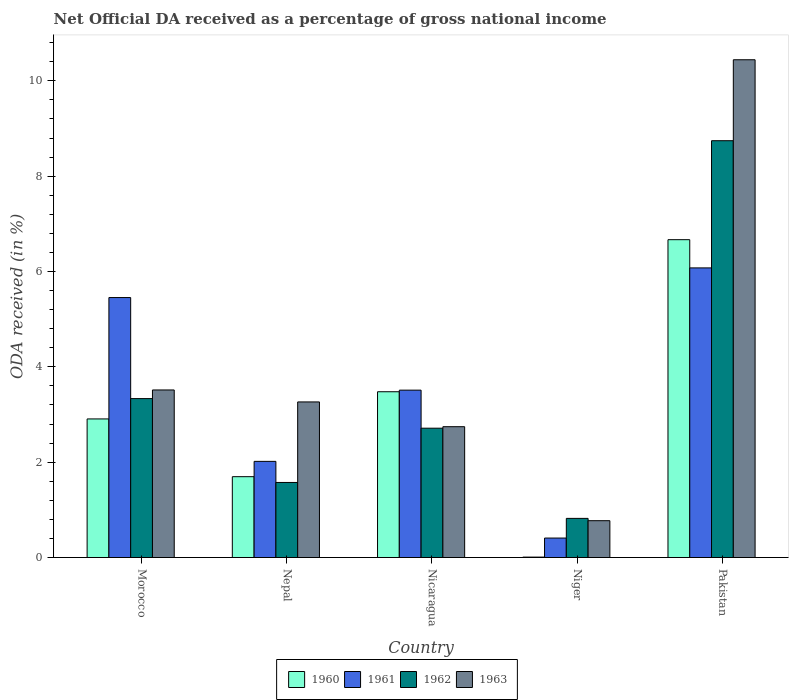How many groups of bars are there?
Offer a very short reply. 5. Are the number of bars per tick equal to the number of legend labels?
Your answer should be compact. Yes. How many bars are there on the 1st tick from the left?
Your response must be concise. 4. How many bars are there on the 3rd tick from the right?
Provide a succinct answer. 4. What is the label of the 4th group of bars from the left?
Make the answer very short. Niger. What is the net official DA received in 1963 in Nepal?
Your answer should be very brief. 3.26. Across all countries, what is the maximum net official DA received in 1963?
Provide a succinct answer. 10.44. Across all countries, what is the minimum net official DA received in 1962?
Make the answer very short. 0.82. In which country was the net official DA received in 1962 maximum?
Offer a terse response. Pakistan. In which country was the net official DA received in 1963 minimum?
Your response must be concise. Niger. What is the total net official DA received in 1962 in the graph?
Your answer should be compact. 17.19. What is the difference between the net official DA received in 1963 in Nicaragua and that in Niger?
Keep it short and to the point. 1.97. What is the difference between the net official DA received in 1963 in Pakistan and the net official DA received in 1962 in Morocco?
Your answer should be compact. 7.11. What is the average net official DA received in 1960 per country?
Provide a succinct answer. 2.95. What is the difference between the net official DA received of/in 1962 and net official DA received of/in 1960 in Nepal?
Give a very brief answer. -0.12. What is the ratio of the net official DA received in 1961 in Nepal to that in Nicaragua?
Ensure brevity in your answer.  0.57. Is the net official DA received in 1961 in Morocco less than that in Nicaragua?
Your answer should be compact. No. What is the difference between the highest and the second highest net official DA received in 1961?
Make the answer very short. -1.94. What is the difference between the highest and the lowest net official DA received in 1960?
Your answer should be compact. 6.66. In how many countries, is the net official DA received in 1962 greater than the average net official DA received in 1962 taken over all countries?
Your answer should be compact. 1. Is it the case that in every country, the sum of the net official DA received in 1963 and net official DA received in 1961 is greater than the net official DA received in 1962?
Your answer should be very brief. Yes. How many bars are there?
Ensure brevity in your answer.  20. Are all the bars in the graph horizontal?
Ensure brevity in your answer.  No. Are the values on the major ticks of Y-axis written in scientific E-notation?
Keep it short and to the point. No. Does the graph contain grids?
Offer a terse response. No. What is the title of the graph?
Provide a short and direct response. Net Official DA received as a percentage of gross national income. Does "1988" appear as one of the legend labels in the graph?
Keep it short and to the point. No. What is the label or title of the Y-axis?
Your answer should be compact. ODA received (in %). What is the ODA received (in %) of 1960 in Morocco?
Give a very brief answer. 2.91. What is the ODA received (in %) in 1961 in Morocco?
Offer a very short reply. 5.45. What is the ODA received (in %) of 1962 in Morocco?
Keep it short and to the point. 3.33. What is the ODA received (in %) of 1963 in Morocco?
Make the answer very short. 3.51. What is the ODA received (in %) in 1960 in Nepal?
Make the answer very short. 1.7. What is the ODA received (in %) of 1961 in Nepal?
Give a very brief answer. 2.02. What is the ODA received (in %) in 1962 in Nepal?
Your answer should be very brief. 1.57. What is the ODA received (in %) of 1963 in Nepal?
Your answer should be very brief. 3.26. What is the ODA received (in %) in 1960 in Nicaragua?
Your answer should be very brief. 3.48. What is the ODA received (in %) in 1961 in Nicaragua?
Offer a terse response. 3.51. What is the ODA received (in %) of 1962 in Nicaragua?
Provide a short and direct response. 2.71. What is the ODA received (in %) in 1963 in Nicaragua?
Your response must be concise. 2.74. What is the ODA received (in %) of 1960 in Niger?
Keep it short and to the point. 0.01. What is the ODA received (in %) in 1961 in Niger?
Your answer should be compact. 0.41. What is the ODA received (in %) of 1962 in Niger?
Provide a short and direct response. 0.82. What is the ODA received (in %) of 1963 in Niger?
Your answer should be compact. 0.77. What is the ODA received (in %) in 1960 in Pakistan?
Your response must be concise. 6.67. What is the ODA received (in %) of 1961 in Pakistan?
Your answer should be compact. 6.08. What is the ODA received (in %) in 1962 in Pakistan?
Keep it short and to the point. 8.74. What is the ODA received (in %) of 1963 in Pakistan?
Ensure brevity in your answer.  10.44. Across all countries, what is the maximum ODA received (in %) in 1960?
Your answer should be very brief. 6.67. Across all countries, what is the maximum ODA received (in %) in 1961?
Make the answer very short. 6.08. Across all countries, what is the maximum ODA received (in %) of 1962?
Your answer should be compact. 8.74. Across all countries, what is the maximum ODA received (in %) of 1963?
Your answer should be very brief. 10.44. Across all countries, what is the minimum ODA received (in %) of 1960?
Ensure brevity in your answer.  0.01. Across all countries, what is the minimum ODA received (in %) of 1961?
Make the answer very short. 0.41. Across all countries, what is the minimum ODA received (in %) in 1962?
Make the answer very short. 0.82. Across all countries, what is the minimum ODA received (in %) of 1963?
Give a very brief answer. 0.77. What is the total ODA received (in %) of 1960 in the graph?
Provide a short and direct response. 14.76. What is the total ODA received (in %) in 1961 in the graph?
Keep it short and to the point. 17.46. What is the total ODA received (in %) in 1962 in the graph?
Ensure brevity in your answer.  17.19. What is the total ODA received (in %) in 1963 in the graph?
Ensure brevity in your answer.  20.74. What is the difference between the ODA received (in %) in 1960 in Morocco and that in Nepal?
Provide a succinct answer. 1.21. What is the difference between the ODA received (in %) in 1961 in Morocco and that in Nepal?
Offer a terse response. 3.44. What is the difference between the ODA received (in %) of 1962 in Morocco and that in Nepal?
Your answer should be compact. 1.76. What is the difference between the ODA received (in %) in 1963 in Morocco and that in Nepal?
Your answer should be very brief. 0.25. What is the difference between the ODA received (in %) of 1960 in Morocco and that in Nicaragua?
Your answer should be very brief. -0.57. What is the difference between the ODA received (in %) of 1961 in Morocco and that in Nicaragua?
Offer a terse response. 1.94. What is the difference between the ODA received (in %) in 1962 in Morocco and that in Nicaragua?
Provide a succinct answer. 0.62. What is the difference between the ODA received (in %) of 1963 in Morocco and that in Nicaragua?
Your answer should be compact. 0.77. What is the difference between the ODA received (in %) in 1960 in Morocco and that in Niger?
Offer a terse response. 2.9. What is the difference between the ODA received (in %) of 1961 in Morocco and that in Niger?
Your answer should be very brief. 5.05. What is the difference between the ODA received (in %) in 1962 in Morocco and that in Niger?
Provide a succinct answer. 2.51. What is the difference between the ODA received (in %) in 1963 in Morocco and that in Niger?
Provide a succinct answer. 2.74. What is the difference between the ODA received (in %) of 1960 in Morocco and that in Pakistan?
Make the answer very short. -3.76. What is the difference between the ODA received (in %) in 1961 in Morocco and that in Pakistan?
Provide a succinct answer. -0.62. What is the difference between the ODA received (in %) of 1962 in Morocco and that in Pakistan?
Give a very brief answer. -5.41. What is the difference between the ODA received (in %) of 1963 in Morocco and that in Pakistan?
Your response must be concise. -6.93. What is the difference between the ODA received (in %) in 1960 in Nepal and that in Nicaragua?
Give a very brief answer. -1.78. What is the difference between the ODA received (in %) of 1961 in Nepal and that in Nicaragua?
Offer a very short reply. -1.49. What is the difference between the ODA received (in %) in 1962 in Nepal and that in Nicaragua?
Provide a short and direct response. -1.14. What is the difference between the ODA received (in %) of 1963 in Nepal and that in Nicaragua?
Your answer should be compact. 0.52. What is the difference between the ODA received (in %) in 1960 in Nepal and that in Niger?
Keep it short and to the point. 1.69. What is the difference between the ODA received (in %) of 1961 in Nepal and that in Niger?
Provide a short and direct response. 1.61. What is the difference between the ODA received (in %) in 1962 in Nepal and that in Niger?
Your answer should be compact. 0.75. What is the difference between the ODA received (in %) of 1963 in Nepal and that in Niger?
Your answer should be very brief. 2.49. What is the difference between the ODA received (in %) of 1960 in Nepal and that in Pakistan?
Provide a short and direct response. -4.97. What is the difference between the ODA received (in %) of 1961 in Nepal and that in Pakistan?
Provide a short and direct response. -4.06. What is the difference between the ODA received (in %) of 1962 in Nepal and that in Pakistan?
Your response must be concise. -7.17. What is the difference between the ODA received (in %) of 1963 in Nepal and that in Pakistan?
Keep it short and to the point. -7.18. What is the difference between the ODA received (in %) in 1960 in Nicaragua and that in Niger?
Offer a terse response. 3.47. What is the difference between the ODA received (in %) of 1961 in Nicaragua and that in Niger?
Keep it short and to the point. 3.1. What is the difference between the ODA received (in %) of 1962 in Nicaragua and that in Niger?
Give a very brief answer. 1.89. What is the difference between the ODA received (in %) of 1963 in Nicaragua and that in Niger?
Your response must be concise. 1.97. What is the difference between the ODA received (in %) in 1960 in Nicaragua and that in Pakistan?
Offer a very short reply. -3.19. What is the difference between the ODA received (in %) of 1961 in Nicaragua and that in Pakistan?
Provide a short and direct response. -2.56. What is the difference between the ODA received (in %) in 1962 in Nicaragua and that in Pakistan?
Give a very brief answer. -6.03. What is the difference between the ODA received (in %) of 1963 in Nicaragua and that in Pakistan?
Your answer should be very brief. -7.7. What is the difference between the ODA received (in %) of 1960 in Niger and that in Pakistan?
Ensure brevity in your answer.  -6.66. What is the difference between the ODA received (in %) in 1961 in Niger and that in Pakistan?
Your response must be concise. -5.67. What is the difference between the ODA received (in %) of 1962 in Niger and that in Pakistan?
Your response must be concise. -7.92. What is the difference between the ODA received (in %) of 1963 in Niger and that in Pakistan?
Your response must be concise. -9.67. What is the difference between the ODA received (in %) of 1960 in Morocco and the ODA received (in %) of 1961 in Nepal?
Offer a terse response. 0.89. What is the difference between the ODA received (in %) of 1960 in Morocco and the ODA received (in %) of 1962 in Nepal?
Make the answer very short. 1.33. What is the difference between the ODA received (in %) of 1960 in Morocco and the ODA received (in %) of 1963 in Nepal?
Ensure brevity in your answer.  -0.36. What is the difference between the ODA received (in %) in 1961 in Morocco and the ODA received (in %) in 1962 in Nepal?
Offer a terse response. 3.88. What is the difference between the ODA received (in %) in 1961 in Morocco and the ODA received (in %) in 1963 in Nepal?
Keep it short and to the point. 2.19. What is the difference between the ODA received (in %) in 1962 in Morocco and the ODA received (in %) in 1963 in Nepal?
Give a very brief answer. 0.07. What is the difference between the ODA received (in %) in 1960 in Morocco and the ODA received (in %) in 1961 in Nicaragua?
Your answer should be very brief. -0.6. What is the difference between the ODA received (in %) in 1960 in Morocco and the ODA received (in %) in 1962 in Nicaragua?
Keep it short and to the point. 0.19. What is the difference between the ODA received (in %) in 1960 in Morocco and the ODA received (in %) in 1963 in Nicaragua?
Ensure brevity in your answer.  0.16. What is the difference between the ODA received (in %) in 1961 in Morocco and the ODA received (in %) in 1962 in Nicaragua?
Offer a very short reply. 2.74. What is the difference between the ODA received (in %) of 1961 in Morocco and the ODA received (in %) of 1963 in Nicaragua?
Your answer should be very brief. 2.71. What is the difference between the ODA received (in %) in 1962 in Morocco and the ODA received (in %) in 1963 in Nicaragua?
Offer a very short reply. 0.59. What is the difference between the ODA received (in %) in 1960 in Morocco and the ODA received (in %) in 1961 in Niger?
Your response must be concise. 2.5. What is the difference between the ODA received (in %) of 1960 in Morocco and the ODA received (in %) of 1962 in Niger?
Provide a short and direct response. 2.09. What is the difference between the ODA received (in %) of 1960 in Morocco and the ODA received (in %) of 1963 in Niger?
Offer a very short reply. 2.13. What is the difference between the ODA received (in %) in 1961 in Morocco and the ODA received (in %) in 1962 in Niger?
Offer a terse response. 4.63. What is the difference between the ODA received (in %) of 1961 in Morocco and the ODA received (in %) of 1963 in Niger?
Offer a very short reply. 4.68. What is the difference between the ODA received (in %) of 1962 in Morocco and the ODA received (in %) of 1963 in Niger?
Provide a succinct answer. 2.56. What is the difference between the ODA received (in %) of 1960 in Morocco and the ODA received (in %) of 1961 in Pakistan?
Offer a terse response. -3.17. What is the difference between the ODA received (in %) of 1960 in Morocco and the ODA received (in %) of 1962 in Pakistan?
Your response must be concise. -5.84. What is the difference between the ODA received (in %) of 1960 in Morocco and the ODA received (in %) of 1963 in Pakistan?
Offer a terse response. -7.53. What is the difference between the ODA received (in %) of 1961 in Morocco and the ODA received (in %) of 1962 in Pakistan?
Make the answer very short. -3.29. What is the difference between the ODA received (in %) in 1961 in Morocco and the ODA received (in %) in 1963 in Pakistan?
Your response must be concise. -4.99. What is the difference between the ODA received (in %) of 1962 in Morocco and the ODA received (in %) of 1963 in Pakistan?
Offer a terse response. -7.11. What is the difference between the ODA received (in %) of 1960 in Nepal and the ODA received (in %) of 1961 in Nicaragua?
Your response must be concise. -1.82. What is the difference between the ODA received (in %) of 1960 in Nepal and the ODA received (in %) of 1962 in Nicaragua?
Ensure brevity in your answer.  -1.02. What is the difference between the ODA received (in %) in 1960 in Nepal and the ODA received (in %) in 1963 in Nicaragua?
Your answer should be very brief. -1.05. What is the difference between the ODA received (in %) of 1961 in Nepal and the ODA received (in %) of 1962 in Nicaragua?
Keep it short and to the point. -0.7. What is the difference between the ODA received (in %) in 1961 in Nepal and the ODA received (in %) in 1963 in Nicaragua?
Provide a short and direct response. -0.73. What is the difference between the ODA received (in %) in 1962 in Nepal and the ODA received (in %) in 1963 in Nicaragua?
Your answer should be very brief. -1.17. What is the difference between the ODA received (in %) of 1960 in Nepal and the ODA received (in %) of 1961 in Niger?
Offer a very short reply. 1.29. What is the difference between the ODA received (in %) of 1960 in Nepal and the ODA received (in %) of 1962 in Niger?
Your response must be concise. 0.87. What is the difference between the ODA received (in %) in 1960 in Nepal and the ODA received (in %) in 1963 in Niger?
Provide a short and direct response. 0.92. What is the difference between the ODA received (in %) in 1961 in Nepal and the ODA received (in %) in 1962 in Niger?
Provide a succinct answer. 1.2. What is the difference between the ODA received (in %) in 1961 in Nepal and the ODA received (in %) in 1963 in Niger?
Offer a terse response. 1.24. What is the difference between the ODA received (in %) of 1962 in Nepal and the ODA received (in %) of 1963 in Niger?
Provide a short and direct response. 0.8. What is the difference between the ODA received (in %) in 1960 in Nepal and the ODA received (in %) in 1961 in Pakistan?
Ensure brevity in your answer.  -4.38. What is the difference between the ODA received (in %) of 1960 in Nepal and the ODA received (in %) of 1962 in Pakistan?
Your answer should be compact. -7.05. What is the difference between the ODA received (in %) in 1960 in Nepal and the ODA received (in %) in 1963 in Pakistan?
Your answer should be very brief. -8.75. What is the difference between the ODA received (in %) of 1961 in Nepal and the ODA received (in %) of 1962 in Pakistan?
Offer a terse response. -6.73. What is the difference between the ODA received (in %) of 1961 in Nepal and the ODA received (in %) of 1963 in Pakistan?
Offer a very short reply. -8.42. What is the difference between the ODA received (in %) in 1962 in Nepal and the ODA received (in %) in 1963 in Pakistan?
Provide a succinct answer. -8.87. What is the difference between the ODA received (in %) of 1960 in Nicaragua and the ODA received (in %) of 1961 in Niger?
Provide a succinct answer. 3.07. What is the difference between the ODA received (in %) in 1960 in Nicaragua and the ODA received (in %) in 1962 in Niger?
Offer a very short reply. 2.66. What is the difference between the ODA received (in %) in 1960 in Nicaragua and the ODA received (in %) in 1963 in Niger?
Your answer should be very brief. 2.71. What is the difference between the ODA received (in %) of 1961 in Nicaragua and the ODA received (in %) of 1962 in Niger?
Your answer should be compact. 2.69. What is the difference between the ODA received (in %) in 1961 in Nicaragua and the ODA received (in %) in 1963 in Niger?
Ensure brevity in your answer.  2.74. What is the difference between the ODA received (in %) in 1962 in Nicaragua and the ODA received (in %) in 1963 in Niger?
Your answer should be very brief. 1.94. What is the difference between the ODA received (in %) of 1960 in Nicaragua and the ODA received (in %) of 1961 in Pakistan?
Your answer should be compact. -2.6. What is the difference between the ODA received (in %) of 1960 in Nicaragua and the ODA received (in %) of 1962 in Pakistan?
Provide a succinct answer. -5.27. What is the difference between the ODA received (in %) in 1960 in Nicaragua and the ODA received (in %) in 1963 in Pakistan?
Give a very brief answer. -6.96. What is the difference between the ODA received (in %) in 1961 in Nicaragua and the ODA received (in %) in 1962 in Pakistan?
Your response must be concise. -5.23. What is the difference between the ODA received (in %) of 1961 in Nicaragua and the ODA received (in %) of 1963 in Pakistan?
Give a very brief answer. -6.93. What is the difference between the ODA received (in %) in 1962 in Nicaragua and the ODA received (in %) in 1963 in Pakistan?
Provide a succinct answer. -7.73. What is the difference between the ODA received (in %) in 1960 in Niger and the ODA received (in %) in 1961 in Pakistan?
Your answer should be compact. -6.07. What is the difference between the ODA received (in %) in 1960 in Niger and the ODA received (in %) in 1962 in Pakistan?
Ensure brevity in your answer.  -8.73. What is the difference between the ODA received (in %) in 1960 in Niger and the ODA received (in %) in 1963 in Pakistan?
Make the answer very short. -10.43. What is the difference between the ODA received (in %) of 1961 in Niger and the ODA received (in %) of 1962 in Pakistan?
Give a very brief answer. -8.34. What is the difference between the ODA received (in %) of 1961 in Niger and the ODA received (in %) of 1963 in Pakistan?
Give a very brief answer. -10.03. What is the difference between the ODA received (in %) of 1962 in Niger and the ODA received (in %) of 1963 in Pakistan?
Provide a succinct answer. -9.62. What is the average ODA received (in %) of 1960 per country?
Provide a short and direct response. 2.95. What is the average ODA received (in %) in 1961 per country?
Your answer should be compact. 3.49. What is the average ODA received (in %) in 1962 per country?
Keep it short and to the point. 3.44. What is the average ODA received (in %) of 1963 per country?
Offer a terse response. 4.15. What is the difference between the ODA received (in %) of 1960 and ODA received (in %) of 1961 in Morocco?
Provide a succinct answer. -2.55. What is the difference between the ODA received (in %) in 1960 and ODA received (in %) in 1962 in Morocco?
Keep it short and to the point. -0.43. What is the difference between the ODA received (in %) in 1960 and ODA received (in %) in 1963 in Morocco?
Provide a succinct answer. -0.61. What is the difference between the ODA received (in %) in 1961 and ODA received (in %) in 1962 in Morocco?
Ensure brevity in your answer.  2.12. What is the difference between the ODA received (in %) in 1961 and ODA received (in %) in 1963 in Morocco?
Provide a short and direct response. 1.94. What is the difference between the ODA received (in %) of 1962 and ODA received (in %) of 1963 in Morocco?
Ensure brevity in your answer.  -0.18. What is the difference between the ODA received (in %) in 1960 and ODA received (in %) in 1961 in Nepal?
Provide a succinct answer. -0.32. What is the difference between the ODA received (in %) of 1960 and ODA received (in %) of 1962 in Nepal?
Offer a very short reply. 0.12. What is the difference between the ODA received (in %) in 1960 and ODA received (in %) in 1963 in Nepal?
Your answer should be compact. -1.57. What is the difference between the ODA received (in %) of 1961 and ODA received (in %) of 1962 in Nepal?
Offer a very short reply. 0.44. What is the difference between the ODA received (in %) in 1961 and ODA received (in %) in 1963 in Nepal?
Provide a short and direct response. -1.25. What is the difference between the ODA received (in %) of 1962 and ODA received (in %) of 1963 in Nepal?
Your response must be concise. -1.69. What is the difference between the ODA received (in %) of 1960 and ODA received (in %) of 1961 in Nicaragua?
Your answer should be very brief. -0.03. What is the difference between the ODA received (in %) in 1960 and ODA received (in %) in 1962 in Nicaragua?
Your answer should be compact. 0.76. What is the difference between the ODA received (in %) in 1960 and ODA received (in %) in 1963 in Nicaragua?
Keep it short and to the point. 0.73. What is the difference between the ODA received (in %) of 1961 and ODA received (in %) of 1962 in Nicaragua?
Provide a short and direct response. 0.8. What is the difference between the ODA received (in %) in 1961 and ODA received (in %) in 1963 in Nicaragua?
Ensure brevity in your answer.  0.77. What is the difference between the ODA received (in %) of 1962 and ODA received (in %) of 1963 in Nicaragua?
Provide a short and direct response. -0.03. What is the difference between the ODA received (in %) of 1960 and ODA received (in %) of 1961 in Niger?
Offer a terse response. -0.4. What is the difference between the ODA received (in %) of 1960 and ODA received (in %) of 1962 in Niger?
Your answer should be very brief. -0.81. What is the difference between the ODA received (in %) of 1960 and ODA received (in %) of 1963 in Niger?
Provide a short and direct response. -0.76. What is the difference between the ODA received (in %) in 1961 and ODA received (in %) in 1962 in Niger?
Provide a short and direct response. -0.41. What is the difference between the ODA received (in %) in 1961 and ODA received (in %) in 1963 in Niger?
Offer a very short reply. -0.36. What is the difference between the ODA received (in %) of 1962 and ODA received (in %) of 1963 in Niger?
Keep it short and to the point. 0.05. What is the difference between the ODA received (in %) in 1960 and ODA received (in %) in 1961 in Pakistan?
Your response must be concise. 0.59. What is the difference between the ODA received (in %) of 1960 and ODA received (in %) of 1962 in Pakistan?
Provide a short and direct response. -2.08. What is the difference between the ODA received (in %) in 1960 and ODA received (in %) in 1963 in Pakistan?
Offer a terse response. -3.77. What is the difference between the ODA received (in %) of 1961 and ODA received (in %) of 1962 in Pakistan?
Keep it short and to the point. -2.67. What is the difference between the ODA received (in %) of 1961 and ODA received (in %) of 1963 in Pakistan?
Offer a very short reply. -4.37. What is the difference between the ODA received (in %) of 1962 and ODA received (in %) of 1963 in Pakistan?
Give a very brief answer. -1.7. What is the ratio of the ODA received (in %) in 1960 in Morocco to that in Nepal?
Make the answer very short. 1.71. What is the ratio of the ODA received (in %) of 1961 in Morocco to that in Nepal?
Provide a short and direct response. 2.7. What is the ratio of the ODA received (in %) in 1962 in Morocco to that in Nepal?
Your response must be concise. 2.12. What is the ratio of the ODA received (in %) in 1960 in Morocco to that in Nicaragua?
Give a very brief answer. 0.84. What is the ratio of the ODA received (in %) in 1961 in Morocco to that in Nicaragua?
Keep it short and to the point. 1.55. What is the ratio of the ODA received (in %) of 1962 in Morocco to that in Nicaragua?
Provide a succinct answer. 1.23. What is the ratio of the ODA received (in %) in 1963 in Morocco to that in Nicaragua?
Your answer should be very brief. 1.28. What is the ratio of the ODA received (in %) in 1960 in Morocco to that in Niger?
Your answer should be compact. 327.61. What is the ratio of the ODA received (in %) in 1961 in Morocco to that in Niger?
Make the answer very short. 13.36. What is the ratio of the ODA received (in %) in 1962 in Morocco to that in Niger?
Your answer should be compact. 4.06. What is the ratio of the ODA received (in %) in 1963 in Morocco to that in Niger?
Provide a succinct answer. 4.55. What is the ratio of the ODA received (in %) of 1960 in Morocco to that in Pakistan?
Keep it short and to the point. 0.44. What is the ratio of the ODA received (in %) of 1961 in Morocco to that in Pakistan?
Offer a terse response. 0.9. What is the ratio of the ODA received (in %) in 1962 in Morocco to that in Pakistan?
Ensure brevity in your answer.  0.38. What is the ratio of the ODA received (in %) in 1963 in Morocco to that in Pakistan?
Your answer should be compact. 0.34. What is the ratio of the ODA received (in %) in 1960 in Nepal to that in Nicaragua?
Provide a short and direct response. 0.49. What is the ratio of the ODA received (in %) of 1961 in Nepal to that in Nicaragua?
Your answer should be compact. 0.57. What is the ratio of the ODA received (in %) of 1962 in Nepal to that in Nicaragua?
Provide a succinct answer. 0.58. What is the ratio of the ODA received (in %) in 1963 in Nepal to that in Nicaragua?
Make the answer very short. 1.19. What is the ratio of the ODA received (in %) in 1960 in Nepal to that in Niger?
Keep it short and to the point. 191.09. What is the ratio of the ODA received (in %) of 1961 in Nepal to that in Niger?
Keep it short and to the point. 4.94. What is the ratio of the ODA received (in %) of 1962 in Nepal to that in Niger?
Make the answer very short. 1.92. What is the ratio of the ODA received (in %) in 1963 in Nepal to that in Niger?
Give a very brief answer. 4.23. What is the ratio of the ODA received (in %) in 1960 in Nepal to that in Pakistan?
Offer a very short reply. 0.25. What is the ratio of the ODA received (in %) in 1961 in Nepal to that in Pakistan?
Give a very brief answer. 0.33. What is the ratio of the ODA received (in %) of 1962 in Nepal to that in Pakistan?
Keep it short and to the point. 0.18. What is the ratio of the ODA received (in %) of 1963 in Nepal to that in Pakistan?
Your response must be concise. 0.31. What is the ratio of the ODA received (in %) of 1960 in Nicaragua to that in Niger?
Offer a terse response. 391.87. What is the ratio of the ODA received (in %) of 1961 in Nicaragua to that in Niger?
Ensure brevity in your answer.  8.6. What is the ratio of the ODA received (in %) of 1962 in Nicaragua to that in Niger?
Keep it short and to the point. 3.3. What is the ratio of the ODA received (in %) of 1963 in Nicaragua to that in Niger?
Ensure brevity in your answer.  3.55. What is the ratio of the ODA received (in %) in 1960 in Nicaragua to that in Pakistan?
Offer a very short reply. 0.52. What is the ratio of the ODA received (in %) of 1961 in Nicaragua to that in Pakistan?
Provide a succinct answer. 0.58. What is the ratio of the ODA received (in %) of 1962 in Nicaragua to that in Pakistan?
Offer a terse response. 0.31. What is the ratio of the ODA received (in %) in 1963 in Nicaragua to that in Pakistan?
Provide a succinct answer. 0.26. What is the ratio of the ODA received (in %) in 1960 in Niger to that in Pakistan?
Make the answer very short. 0. What is the ratio of the ODA received (in %) in 1961 in Niger to that in Pakistan?
Your response must be concise. 0.07. What is the ratio of the ODA received (in %) in 1962 in Niger to that in Pakistan?
Provide a short and direct response. 0.09. What is the ratio of the ODA received (in %) of 1963 in Niger to that in Pakistan?
Keep it short and to the point. 0.07. What is the difference between the highest and the second highest ODA received (in %) in 1960?
Offer a very short reply. 3.19. What is the difference between the highest and the second highest ODA received (in %) in 1961?
Ensure brevity in your answer.  0.62. What is the difference between the highest and the second highest ODA received (in %) of 1962?
Make the answer very short. 5.41. What is the difference between the highest and the second highest ODA received (in %) in 1963?
Your response must be concise. 6.93. What is the difference between the highest and the lowest ODA received (in %) of 1960?
Give a very brief answer. 6.66. What is the difference between the highest and the lowest ODA received (in %) in 1961?
Your answer should be compact. 5.67. What is the difference between the highest and the lowest ODA received (in %) in 1962?
Provide a succinct answer. 7.92. What is the difference between the highest and the lowest ODA received (in %) in 1963?
Keep it short and to the point. 9.67. 